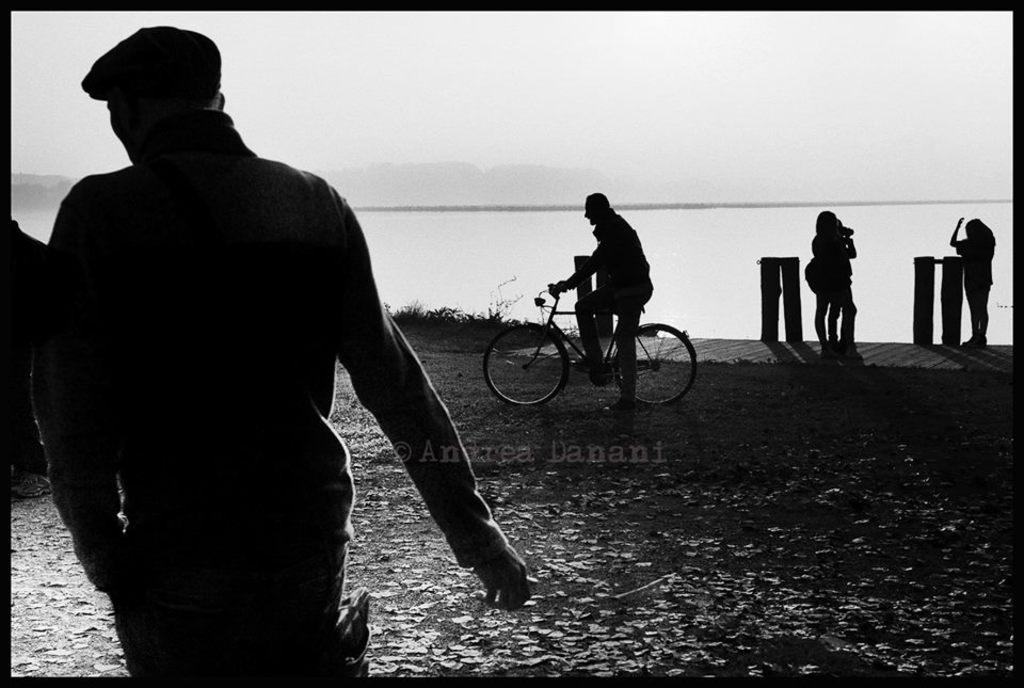What is happening on the left side of the image? There is a man on the left side of the image. What activity is taking place in the middle of the image? A person is riding a bicycle in the middle of the image. How many people are on the right side of the image? There are three people on the right side of the image. What can be seen in the background of the image? Water and the sky are visible in the background of the image. What type of verse can be heard being recited by the man on the left side of the image? There is no indication in the image that the man is reciting any verse, so it cannot be determined from the picture. 